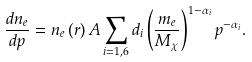Convert formula to latex. <formula><loc_0><loc_0><loc_500><loc_500>\frac { d n _ { e } } { d p } = n _ { e } \left ( r \right ) A \sum _ { i = 1 , 6 } d _ { i } \left ( \frac { m _ { e } } { M _ { \chi } } \right ) ^ { 1 - \alpha _ { i } } p ^ { - \alpha _ { i } } .</formula> 